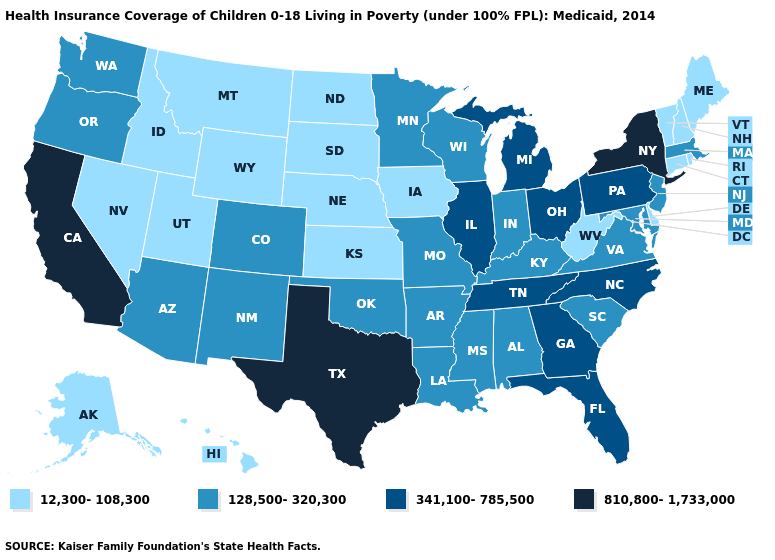What is the value of Maryland?
Write a very short answer. 128,500-320,300. What is the value of Oklahoma?
Give a very brief answer. 128,500-320,300. What is the value of New York?
Quick response, please. 810,800-1,733,000. Among the states that border New York , does New Jersey have the lowest value?
Concise answer only. No. Does the first symbol in the legend represent the smallest category?
Give a very brief answer. Yes. Which states hav the highest value in the Northeast?
Concise answer only. New York. What is the highest value in the MidWest ?
Write a very short answer. 341,100-785,500. What is the lowest value in states that border Michigan?
Concise answer only. 128,500-320,300. Does Texas have a higher value than Ohio?
Keep it brief. Yes. What is the value of Arizona?
Keep it brief. 128,500-320,300. Among the states that border New York , which have the highest value?
Keep it brief. Pennsylvania. Does New Hampshire have a higher value than California?
Keep it brief. No. Does Kansas have the highest value in the USA?
Short answer required. No. Name the states that have a value in the range 810,800-1,733,000?
Quick response, please. California, New York, Texas. Which states have the lowest value in the USA?
Be succinct. Alaska, Connecticut, Delaware, Hawaii, Idaho, Iowa, Kansas, Maine, Montana, Nebraska, Nevada, New Hampshire, North Dakota, Rhode Island, South Dakota, Utah, Vermont, West Virginia, Wyoming. 